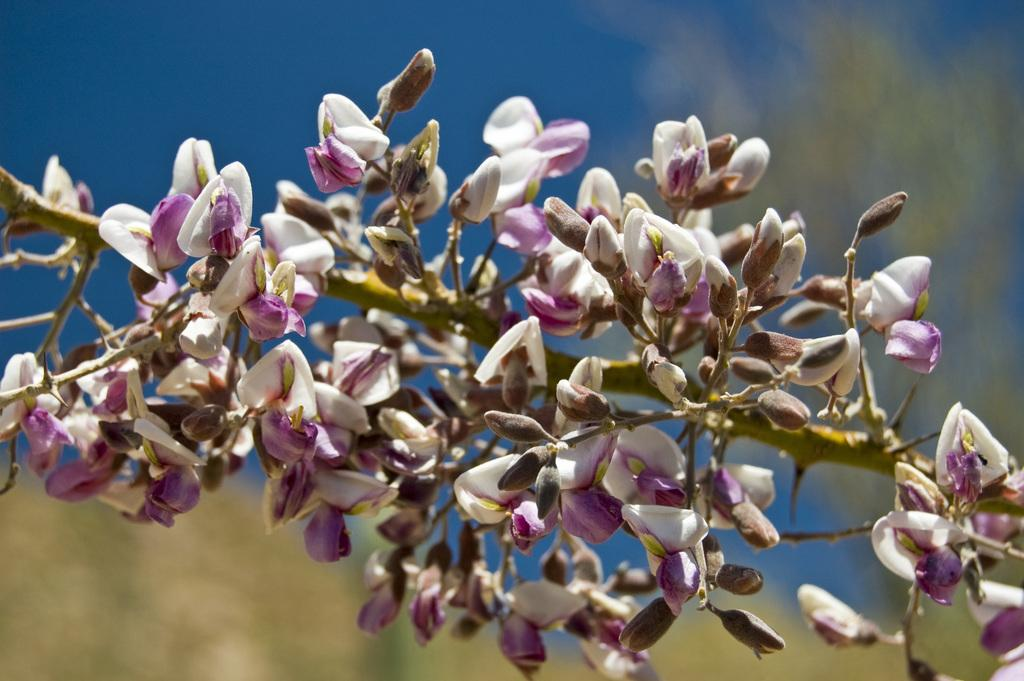What type of plants can be seen in the image? A: There are flowers in the image. What stage of growth are the flowers in? There are buds in the image, indicating that some flowers are still in the process of blooming. What colors are the flowers in the image? The flowers are in white and pink colors. Can you describe the background of the image? The background of the image is blurred. How many feathers can be seen on the hen in the image? There is no hen present in the image; it features flowers and buds. What type of police equipment can be seen in the image? There is no police equipment present in the image; it features flowers and buds. 